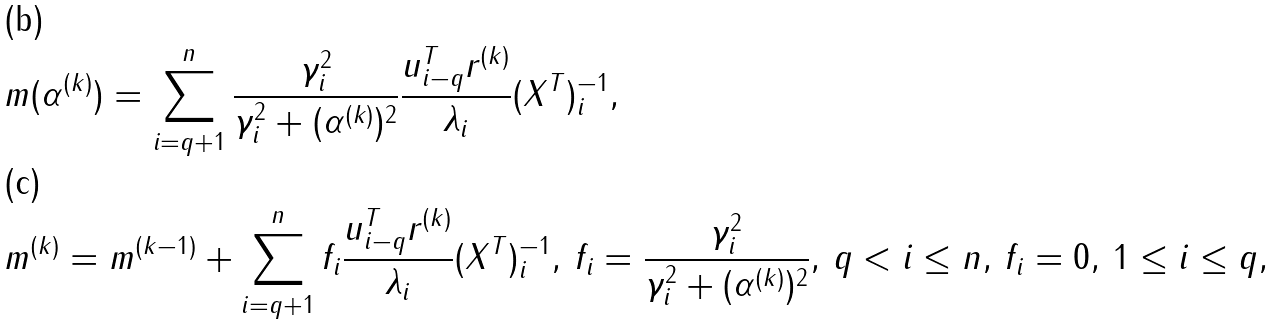Convert formula to latex. <formula><loc_0><loc_0><loc_500><loc_500>& m ( \alpha ^ { ( k ) } ) = \sum _ { i = q + 1 } ^ { n } \frac { \gamma ^ { 2 } _ { i } } { \gamma ^ { 2 } _ { i } + ( \alpha ^ { ( k ) } ) ^ { 2 } } \frac { u ^ { T } _ { i - q } r ^ { ( k ) } } { \lambda _ { i } } ( X ^ { T } ) ^ { - 1 } _ { i } , \\ & m ^ { ( k ) } = m ^ { ( k - 1 ) } + \sum _ { i = q + 1 } ^ { n } f _ { i } \frac { u ^ { T } _ { i - q } r ^ { ( k ) } } { \lambda _ { i } } ( X ^ { T } ) ^ { - 1 } _ { i } , \, f _ { i } = \frac { \gamma ^ { 2 } _ { i } } { \gamma ^ { 2 } _ { i } + ( \alpha ^ { ( k ) } ) ^ { 2 } } , \, q < i \leq n , \, f _ { i } = 0 , \, 1 \leq i \leq q ,</formula> 